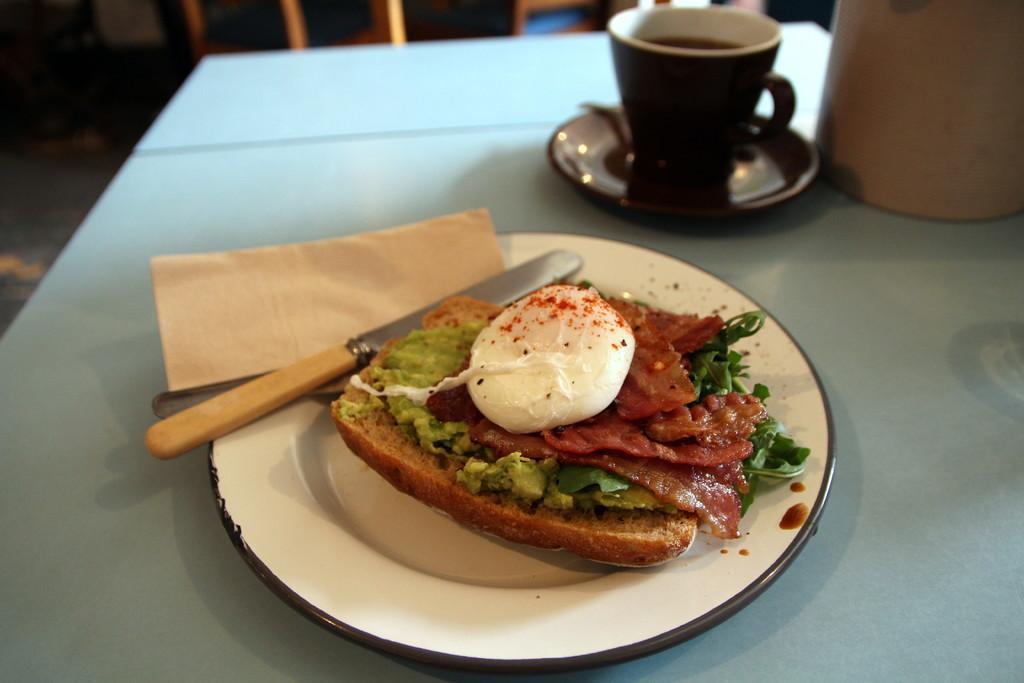Please provide a concise description of this image. In the foreground of the picture there is a table, on the table there is a plate, in the plate there is a knife and a spoon and a sandwich. On the table there is a saucer and a cup and a jar. In the background there is a chair. 